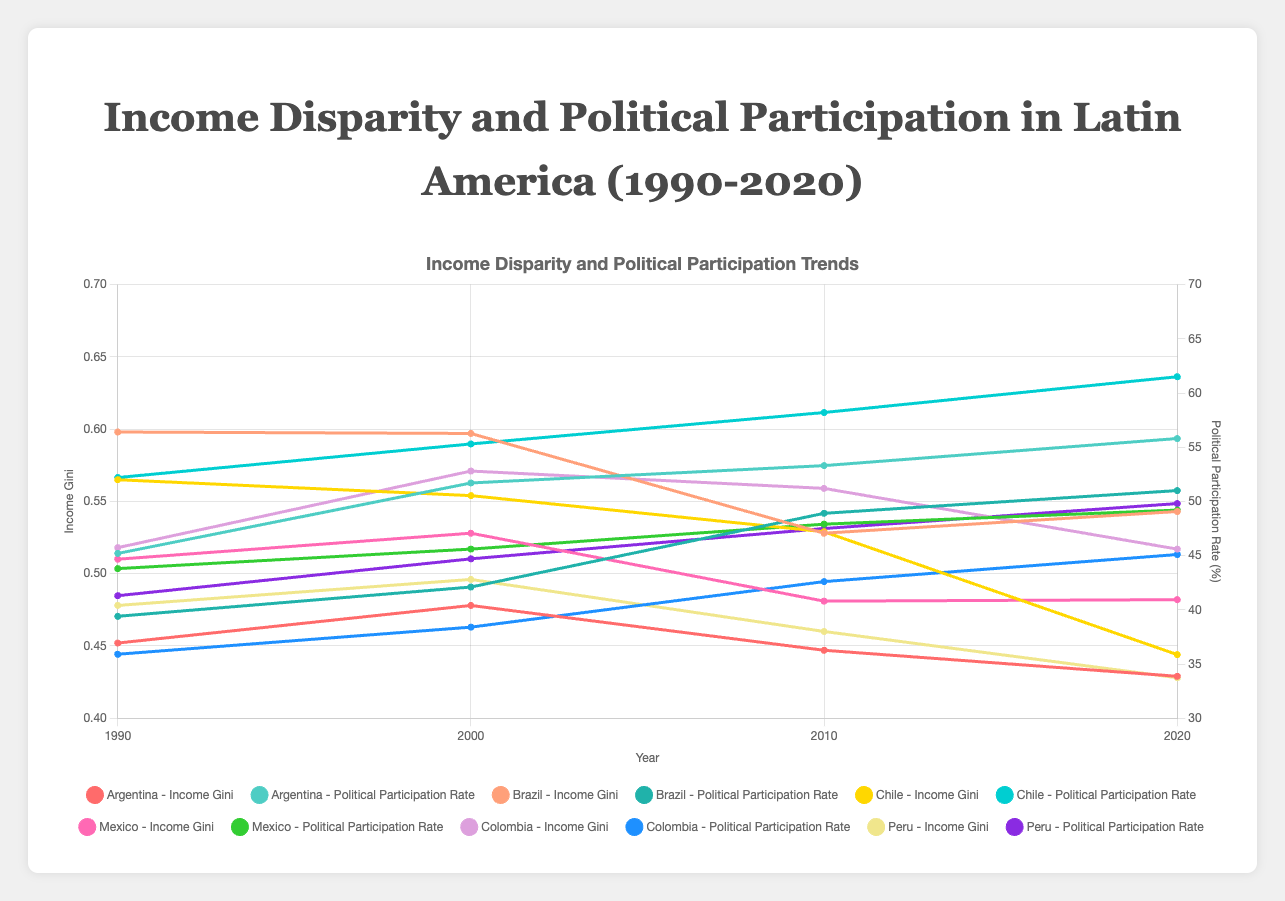What is the trend in income Gini for Argentina from 1990 to 2020? Observing the graph for Argentina, the income Gini starts at 0.452 in 1990, rises to 0.478 in 2000, decreases to 0.447 in 2010, and further drops to 0.429 in 2020. This shows an initial increase followed by a steady decrease over the years.
Answer: Decreased overall Which country had the highest political participation rate in the year 2020? By examining the 2020 data points on the graph, Chile has the highest political participation rate at 61.5%.
Answer: Chile How did Brazil's income Gini change from 1990 to 2020, and how does it compare with Colombia's change in the same period? Brazil’s income Gini started at 0.598 in 1990 and was 0.543 in 2020, indicating a decrease. In contrast, Colombia's income Gini started at 0.518 and ended at 0.517, showing almost no change.
Answer: Brazil decreased, Colombia remained almost unchanged Between 1990 and 2020, which country had the most significant improvement in income disparity? By looking at the change in income Gini values from 1990 to 2020 across all countries, Chile had the most significant decrease from 0.565 to 0.444.
Answer: Chile What is the average political participation rate in Mexico across all the years shown? The political participation rates for Mexico are 43.8 in 1990, 45.6 in 2000, 47.9 in 2010, and 49.2 in 2020. Summing these gives 186.5, and dividing by 4 gives an average of 46.625.
Answer: 46.625 In which decade did Argentina experience the largest drop in its income Gini? Argentina's income Gini dropped the most from 2000 to 2010, decreasing from 0.478 to 0.447.
Answer: 2000-2010 Compare the political participation rate trends for Argentina and Brazil. Argentina shows a steady increase from 45.2% in 1990 to 55.8% in 2020, whereas Brazil shows a less steep increase from 39.4% to 51%. Argentina's increase is more pronounced.
Answer: Argentina’s increase is more pronounced Which two countries had a decrease in income Gini in every decade shown? Observing the graph, Argentina and Chile show a consistent decade-over-decade decrease in income Gini.
Answer: Argentina and Chile 